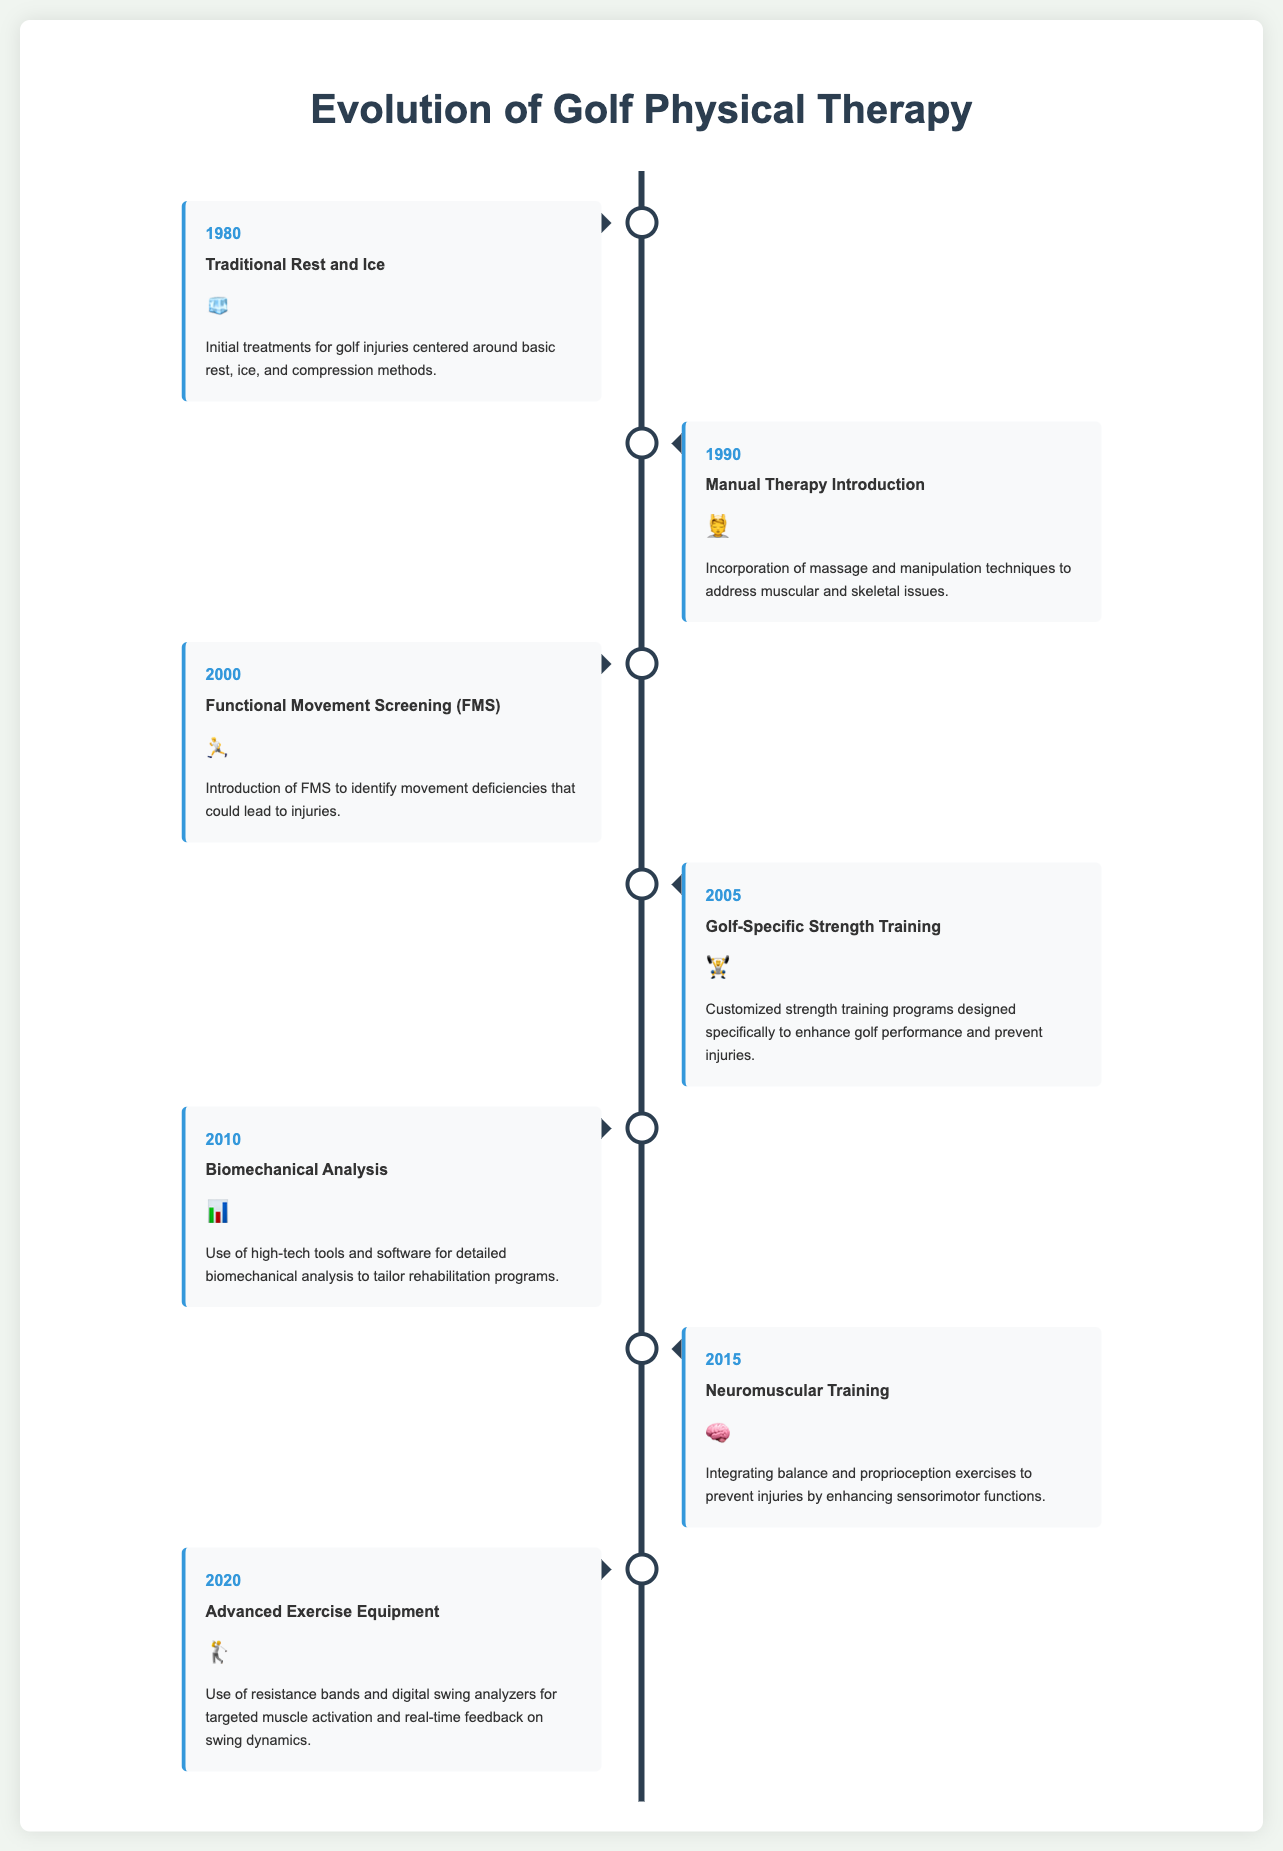What year did the introduction of Functional Movement Screening (FMS) occur? The introduction of FMS is marked in the document as taking place in the year 2000.
Answer: 2000 What icon represents Golf-Specific Strength Training? The document uses the icon of a weightlifter to symbolize Golf-Specific Strength Training, which is shown in 2005.
Answer: 🏋️ What was the primary focus of treatments in 1980? The treatments in 1980 centered around basic rest, ice, and compression methods as indicated in the description.
Answer: Traditional Rest and Ice Which technique was introduced in 2015? The document states that Neuromuscular Training was introduced in 2015, which integrates balance and proprioception exercises.
Answer: Neuromuscular Training How many major advancements are highlighted in the timeline? The document features a total of 7 major advancements in golf rehabilitation techniques listed within the timeline.
Answer: 7 What type of analysis began in 2010? The document indicates that Biomechanical Analysis was the new focus introduced in 2010 to tailor rehabilitation programs.
Answer: Biomechanical Analysis What exercise type was emphasized in 2005? Customized strength training programs designed specifically for golf performance enhancement were emphasized in 2005.
Answer: Golf-Specific Strength Training Which milestone directly preceded Advanced Exercise Equipment? The milestone right before 2020's Advanced Exercise Equipment was the introduction of Neuromuscular Training in 2015.
Answer: Neuromuscular Training 